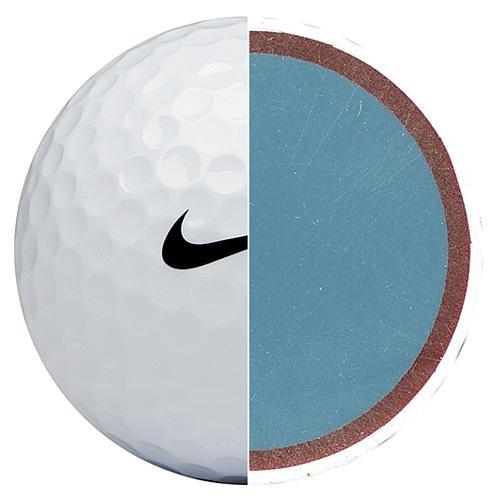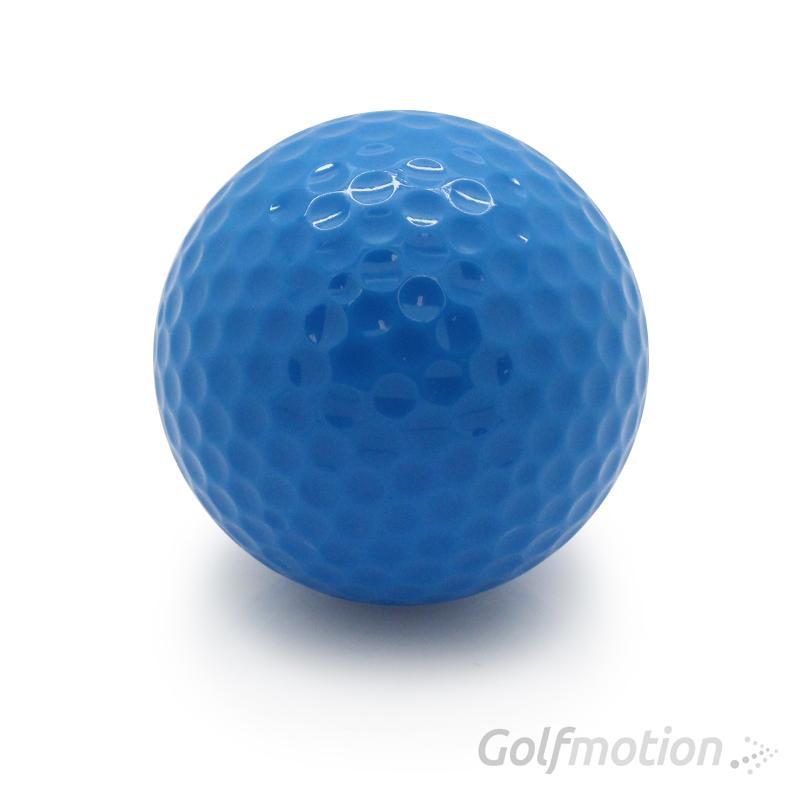The first image is the image on the left, the second image is the image on the right. For the images displayed, is the sentence "An image shows a golf ball bisected vertically, with its blue interior showing on the right side of the ball." factually correct? Answer yes or no. Yes. 